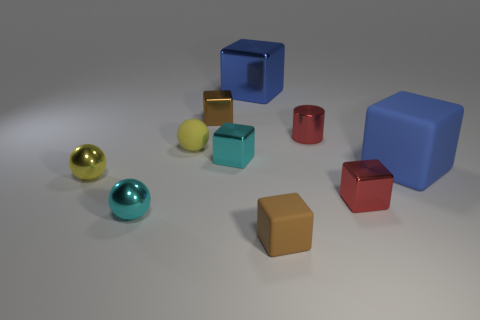How many other objects are the same material as the red cylinder?
Give a very brief answer. 6. The blue matte cube has what size?
Ensure brevity in your answer.  Large. Are there any red objects of the same shape as the tiny yellow matte object?
Keep it short and to the point. No. What number of objects are big blue cubes or tiny cyan things that are on the right side of the small yellow matte ball?
Your answer should be compact. 3. There is a cube that is to the left of the cyan cube; what color is it?
Offer a very short reply. Brown. Does the matte cube behind the brown rubber object have the same size as the blue thing that is left of the red shiny cube?
Your answer should be compact. Yes. Is there another red metal cylinder that has the same size as the cylinder?
Offer a very short reply. No. How many big blue things are in front of the small cyan thing that is in front of the cyan shiny cube?
Your response must be concise. 0. There is a small red shiny block; how many tiny cyan things are behind it?
Make the answer very short. 1. Does the large rubber cube have the same color as the big metallic block?
Your response must be concise. Yes. 